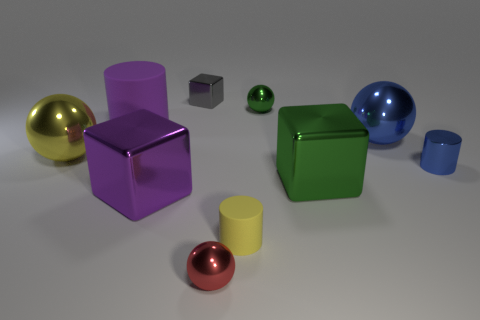There is a shiny object that is the same color as the small matte thing; what is its shape?
Your answer should be very brief. Sphere. What number of other objects are the same shape as the red metal thing?
Keep it short and to the point. 3. What size is the thing that is both to the left of the big green shiny thing and right of the tiny yellow rubber cylinder?
Provide a short and direct response. Small. What number of rubber objects are either red objects or blue cylinders?
Your response must be concise. 0. Do the rubber thing that is to the right of the tiny gray object and the matte thing that is to the left of the yellow rubber thing have the same shape?
Your answer should be very brief. Yes. Are there any red objects made of the same material as the big green object?
Make the answer very short. Yes. The small metal cylinder is what color?
Give a very brief answer. Blue. What size is the cube to the right of the red metallic sphere?
Make the answer very short. Large. How many balls have the same color as the small matte object?
Provide a succinct answer. 1. There is a large cube that is right of the tiny gray metal object; is there a large green cube that is in front of it?
Your response must be concise. No. 